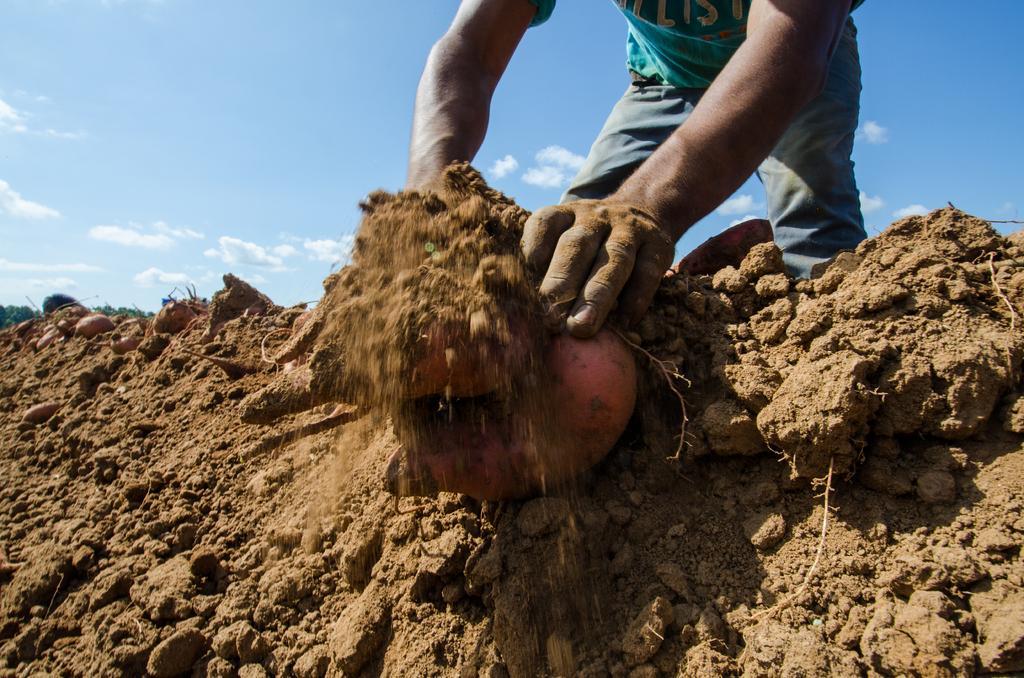Could you give a brief overview of what you see in this image? In this picture, we see a man in the blue T-shirt is pulling out the vegetable which looks like an onion or a beetroot. Beside that, we see the soil. In the background, we see the clouds and the sky, which is blue in color. 